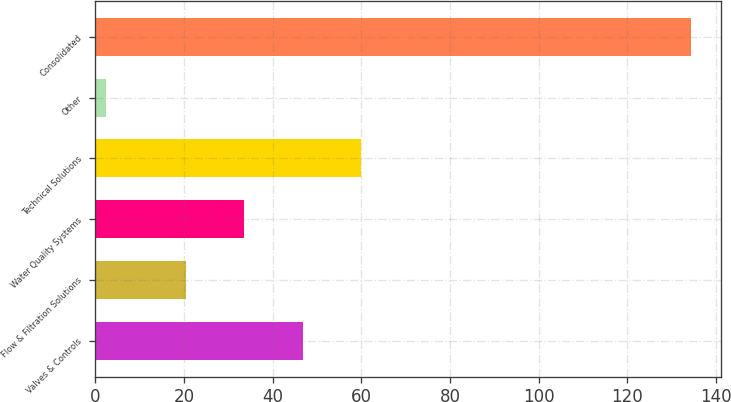<chart> <loc_0><loc_0><loc_500><loc_500><bar_chart><fcel>Valves & Controls<fcel>Flow & Filtration Solutions<fcel>Water Quality Systems<fcel>Technical Solutions<fcel>Other<fcel>Consolidated<nl><fcel>46.78<fcel>20.4<fcel>33.59<fcel>59.97<fcel>2.4<fcel>134.3<nl></chart> 